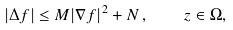<formula> <loc_0><loc_0><loc_500><loc_500>| \Delta f | \leq M | \nabla f | ^ { 2 } + N \, , \quad z \in \Omega ,</formula> 